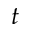<formula> <loc_0><loc_0><loc_500><loc_500>t</formula> 